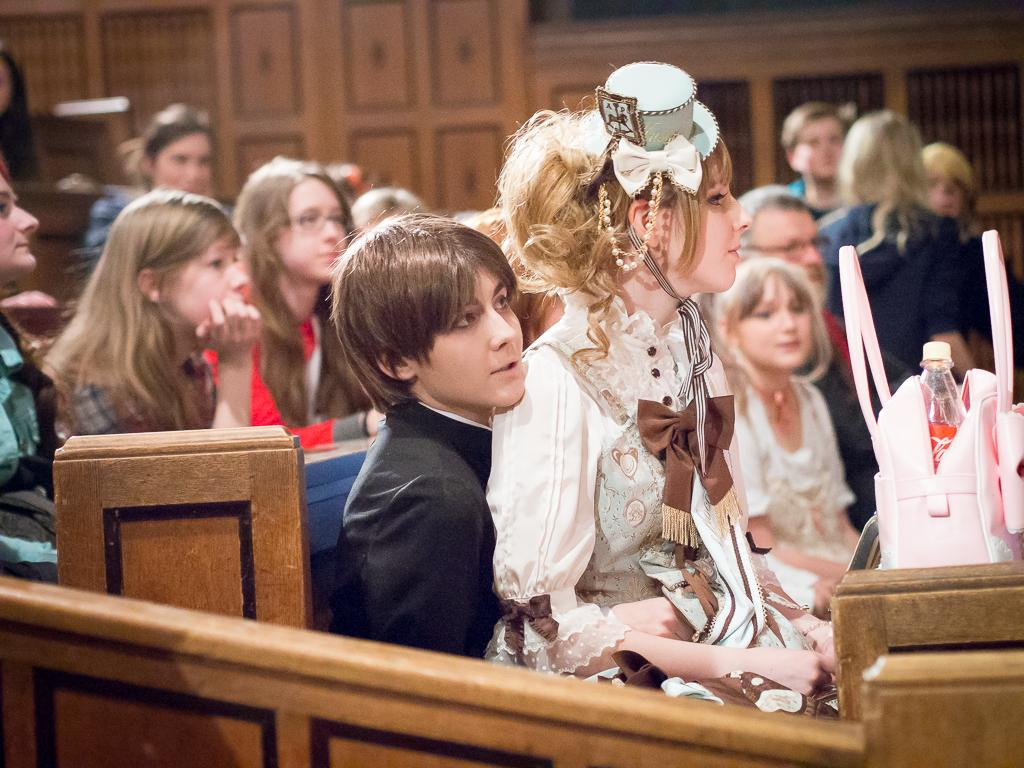Who is present in the image? There are boys and girls in the image. What are the boys and girls doing in the image? The boys and girls are sitting on a bench. What can be seen on the right side of the image? There is a bag on the right side of the image. What is inside the bag? There is a bottle inside the bag. What type of pollution can be seen in the image? There is no pollution visible in the image. What type of trousers are the boys wearing in the image? The provided facts do not mention the type of trousers the boys are wearing. 